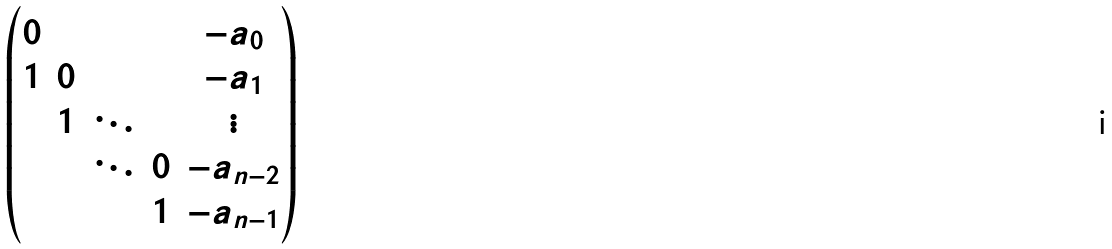<formula> <loc_0><loc_0><loc_500><loc_500>\begin{pmatrix} 0 & & & & - a _ { 0 } \\ 1 & 0 & & & - a _ { 1 } \\ & 1 & \ddots & & \vdots \\ & & \ddots & 0 & - a _ { n - 2 } \\ & & & 1 & - a _ { n - 1 } \end{pmatrix}</formula> 